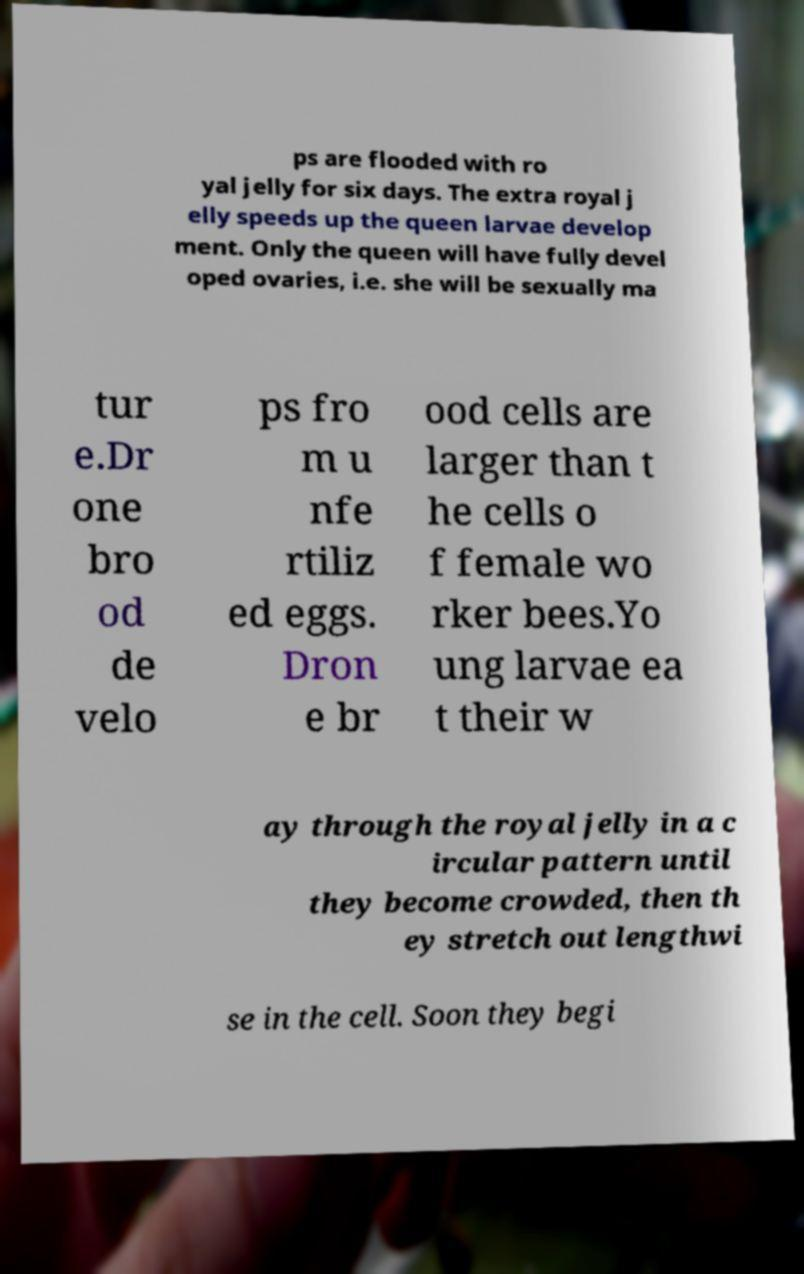I need the written content from this picture converted into text. Can you do that? ps are flooded with ro yal jelly for six days. The extra royal j elly speeds up the queen larvae develop ment. Only the queen will have fully devel oped ovaries, i.e. she will be sexually ma tur e.Dr one bro od de velo ps fro m u nfe rtiliz ed eggs. Dron e br ood cells are larger than t he cells o f female wo rker bees.Yo ung larvae ea t their w ay through the royal jelly in a c ircular pattern until they become crowded, then th ey stretch out lengthwi se in the cell. Soon they begi 